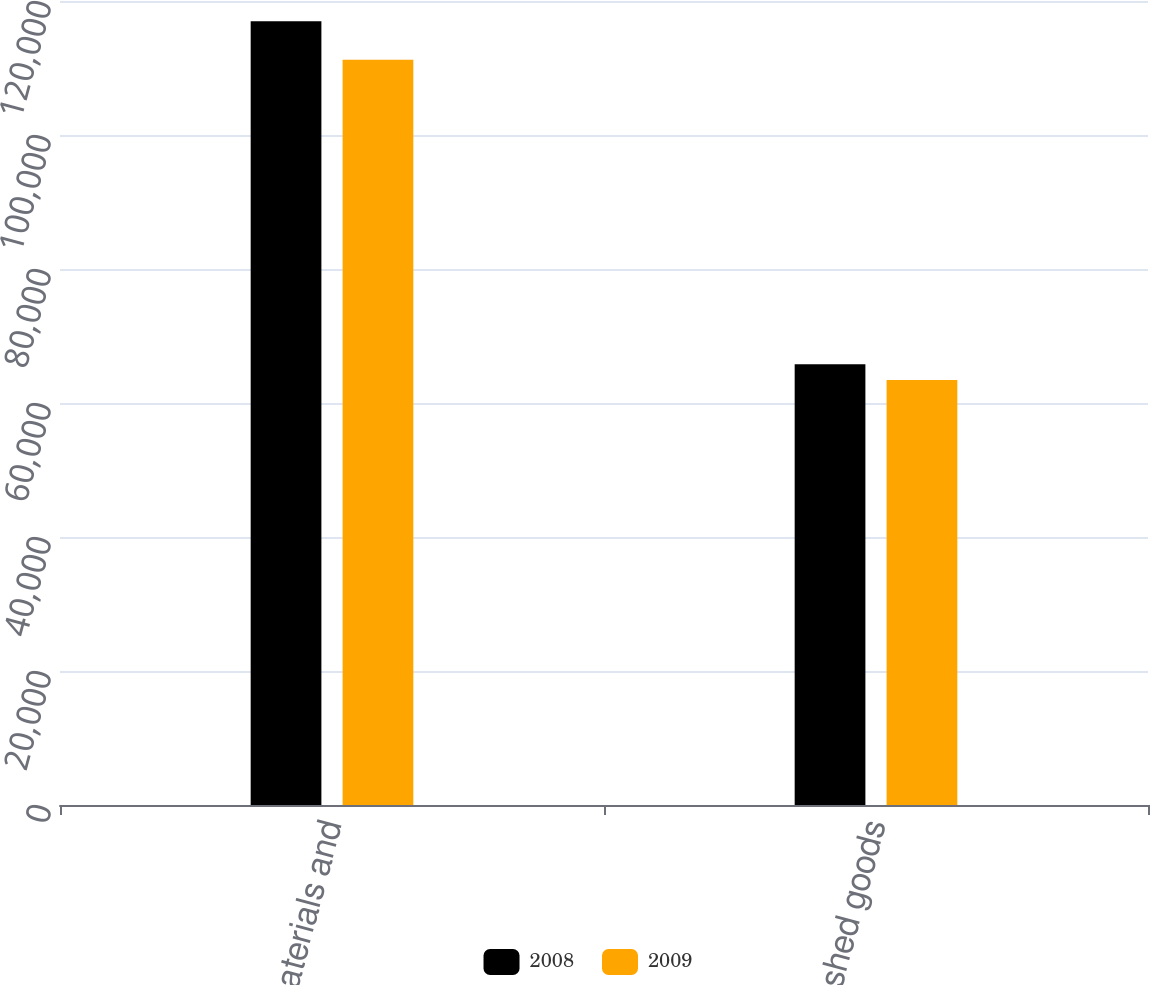Convert chart. <chart><loc_0><loc_0><loc_500><loc_500><stacked_bar_chart><ecel><fcel>Raw materials and<fcel>Finished goods<nl><fcel>2008<fcel>116983<fcel>65797<nl><fcel>2009<fcel>111217<fcel>63450<nl></chart> 